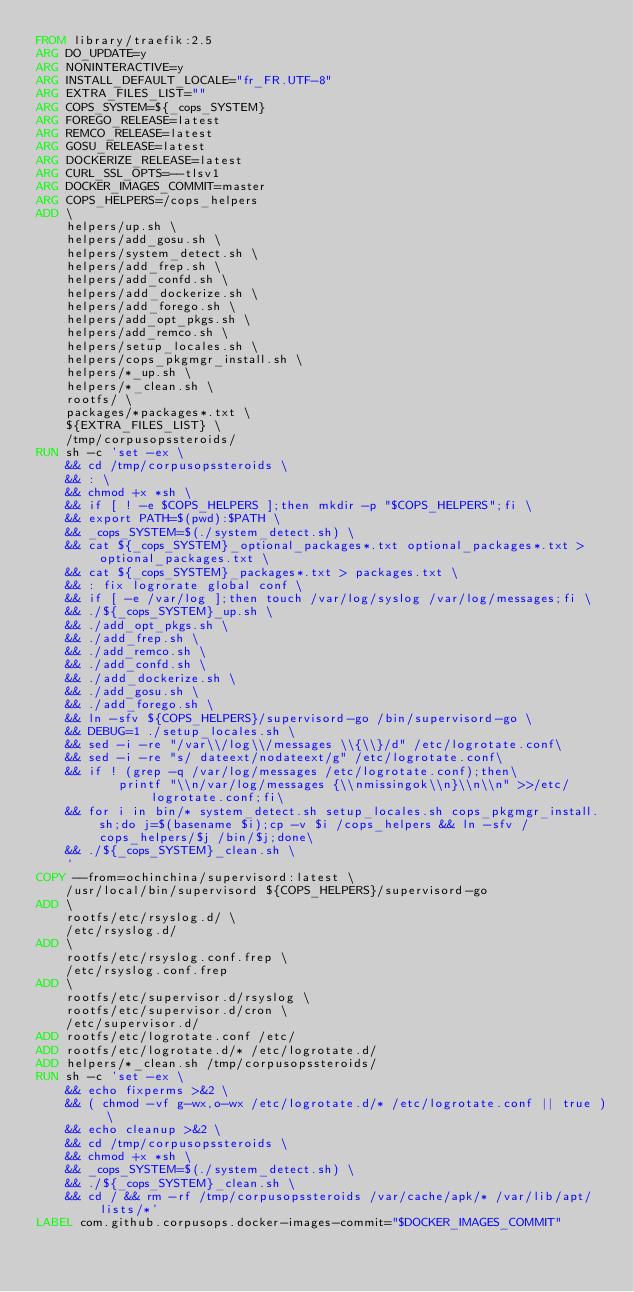<code> <loc_0><loc_0><loc_500><loc_500><_Dockerfile_>FROM library/traefik:2.5
ARG DO_UPDATE=y
ARG NONINTERACTIVE=y
ARG INSTALL_DEFAULT_LOCALE="fr_FR.UTF-8"
ARG EXTRA_FILES_LIST=""
ARG COPS_SYSTEM=${_cops_SYSTEM}
ARG FOREGO_RELEASE=latest
ARG REMCO_RELEASE=latest
ARG GOSU_RELEASE=latest
ARG DOCKERIZE_RELEASE=latest
ARG CURL_SSL_OPTS=--tlsv1
ARG DOCKER_IMAGES_COMMIT=master
ARG COPS_HELPERS=/cops_helpers
ADD \
    helpers/up.sh \
    helpers/add_gosu.sh \
    helpers/system_detect.sh \
    helpers/add_frep.sh \
    helpers/add_confd.sh \
    helpers/add_dockerize.sh \
    helpers/add_forego.sh \
    helpers/add_opt_pkgs.sh \
    helpers/add_remco.sh \
    helpers/setup_locales.sh \
    helpers/cops_pkgmgr_install.sh \
    helpers/*_up.sh \
    helpers/*_clean.sh \
    rootfs/ \
    packages/*packages*.txt \
    ${EXTRA_FILES_LIST} \
    /tmp/corpusopssteroids/
RUN sh -c 'set -ex \
    && cd /tmp/corpusopssteroids \
    && : \
    && chmod +x *sh \
    && if [ ! -e $COPS_HELPERS ];then mkdir -p "$COPS_HELPERS";fi \
    && export PATH=$(pwd):$PATH \
    && _cops_SYSTEM=$(./system_detect.sh) \
    && cat ${_cops_SYSTEM}_optional_packages*.txt optional_packages*.txt > optional_packages.txt \
    && cat ${_cops_SYSTEM}_packages*.txt > packages.txt \
    && : fix logrorate global conf \
    && if [ -e /var/log ];then touch /var/log/syslog /var/log/messages;fi \
    && ./${_cops_SYSTEM}_up.sh \
    && ./add_opt_pkgs.sh \
    && ./add_frep.sh \
    && ./add_remco.sh \
    && ./add_confd.sh \
    && ./add_dockerize.sh \
    && ./add_gosu.sh \
    && ./add_forego.sh \
    && ln -sfv ${COPS_HELPERS}/supervisord-go /bin/supervisord-go \
    && DEBUG=1 ./setup_locales.sh \
    && sed -i -re "/var\\/log\\/messages \\{\\}/d" /etc/logrotate.conf\
    && sed -i -re "s/ dateext/nodateext/g" /etc/logrotate.conf\
    && if ! (grep -q /var/log/messages /etc/logrotate.conf);then\
           printf "\\n/var/log/messages {\\nmissingok\\n}\\n\\n" >>/etc/logrotate.conf;fi\
    && for i in bin/* system_detect.sh setup_locales.sh cops_pkgmgr_install.sh;do j=$(basename $i);cp -v $i /cops_helpers && ln -sfv /cops_helpers/$j /bin/$j;done\
    && ./${_cops_SYSTEM}_clean.sh \
    '
COPY --from=ochinchina/supervisord:latest \
    /usr/local/bin/supervisord ${COPS_HELPERS}/supervisord-go
ADD \
    rootfs/etc/rsyslog.d/ \
    /etc/rsyslog.d/
ADD \
    rootfs/etc/rsyslog.conf.frep \
    /etc/rsyslog.conf.frep
ADD \
    rootfs/etc/supervisor.d/rsyslog \
    rootfs/etc/supervisor.d/cron \
    /etc/supervisor.d/
ADD rootfs/etc/logrotate.conf /etc/
ADD rootfs/etc/logrotate.d/* /etc/logrotate.d/
ADD helpers/*_clean.sh /tmp/corpusopssteroids/
RUN sh -c 'set -ex \
    && echo fixperms >&2 \
    && ( chmod -vf g-wx,o-wx /etc/logrotate.d/* /etc/logrotate.conf || true ) \
    && echo cleanup >&2 \
    && cd /tmp/corpusopssteroids \
    && chmod +x *sh \
    && _cops_SYSTEM=$(./system_detect.sh) \
    && ./${_cops_SYSTEM}_clean.sh \
    && cd / && rm -rf /tmp/corpusopssteroids /var/cache/apk/* /var/lib/apt/lists/*'
LABEL com.github.corpusops.docker-images-commit="$DOCKER_IMAGES_COMMIT"
</code> 